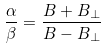<formula> <loc_0><loc_0><loc_500><loc_500>\frac { \alpha } { \beta } = \frac { B + B _ { \perp } } { B - B _ { \perp } }</formula> 